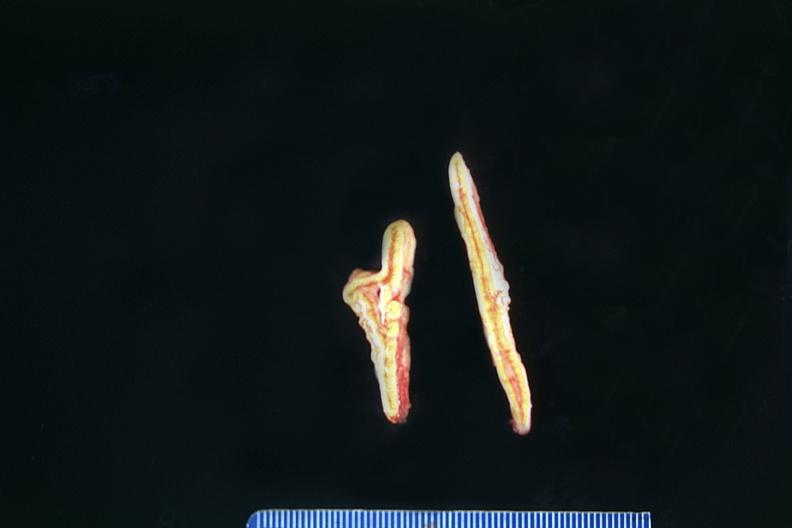s endocrine present?
Answer the question using a single word or phrase. Yes 